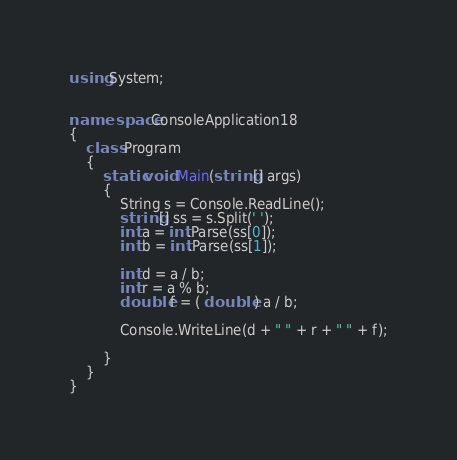Convert code to text. <code><loc_0><loc_0><loc_500><loc_500><_C#_>using System;


namespace ConsoleApplication18
{
    class Program
    {
        static void Main(string[] args)
        {
            String s = Console.ReadLine();
            string[] ss = s.Split(' ');
            int a = int.Parse(ss[0]);
            int b = int.Parse(ss[1]);

            int d = a / b;
            int r = a % b;
            double f = ( double ) a / b;
         
            Console.WriteLine(d + " " + r + " " + f);

        }
    }
}</code> 